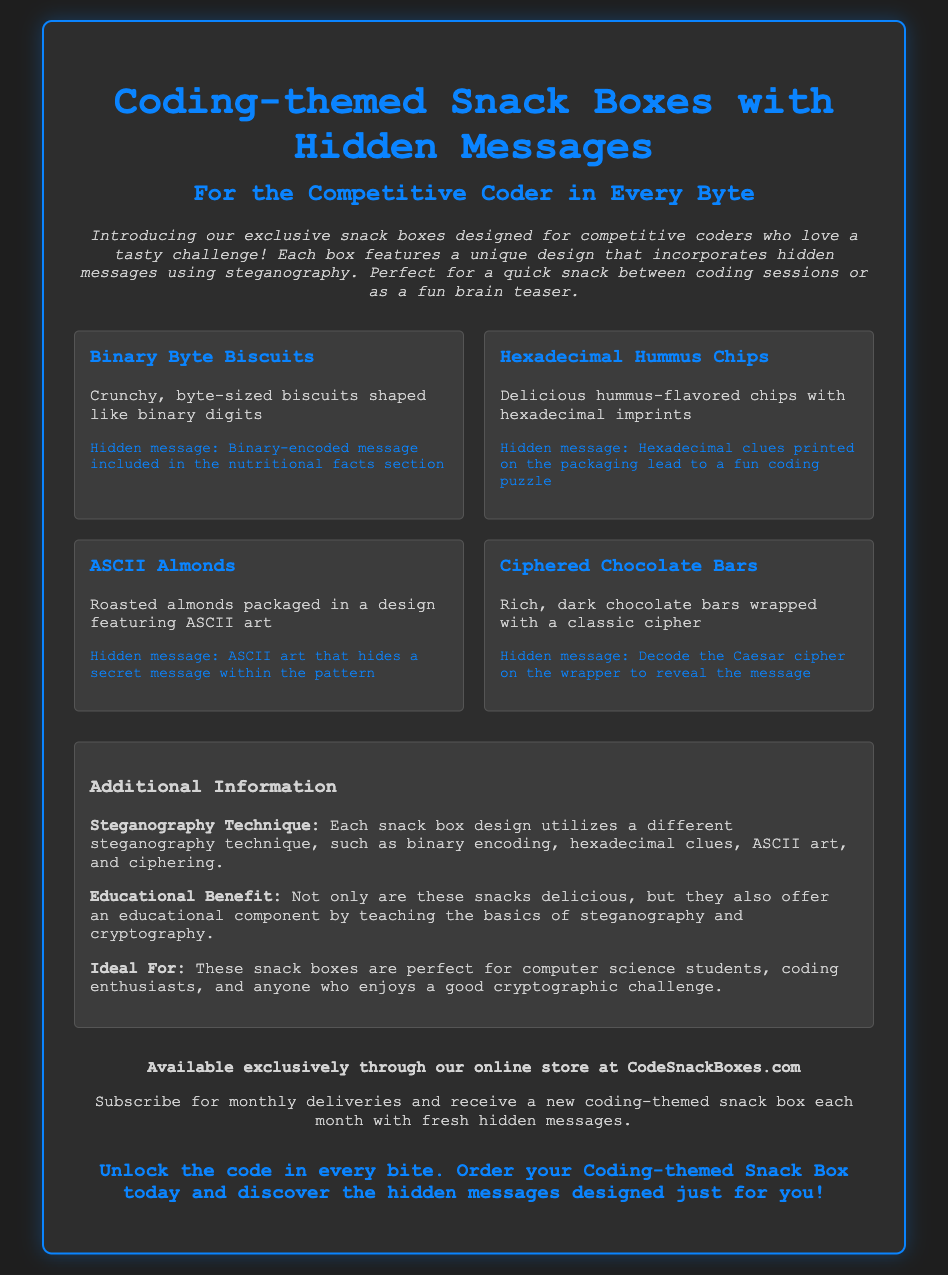What is the name of the product? The title of the product is displayed prominently at the top of the document, stating that it is "Coding-themed Snack Boxes with Hidden Messages."
Answer: Coding-themed Snack Boxes with Hidden Messages What is the ideal audience for these snack boxes? The document mentions that the snack boxes are perfect for "computer science students, coding enthusiasts, and anyone who enjoys a good cryptographic challenge."
Answer: Computer science students, coding enthusiasts, and anyone who enjoys a good cryptographic challenge How many types of snacks are mentioned? The document lists four distinct snack types, which are Binary Byte Biscuits, Hexadecimal Hummus Chips, ASCII Almonds, and Ciphered Chocolate Bars.
Answer: Four What hidden message technique is used for Binary Byte Biscuits? The documentation specifies that the hidden message for Binary Byte Biscuits is encoded in the "nutritional facts section" using binary encoding.
Answer: Binary-encoded message included in the nutritional facts section What is a benefit of this product according to the document? The document states that these snacks offer "an educational component by teaching the basics of steganography and cryptography."
Answer: Educational component by teaching the basics of steganography and cryptography Where can these snack boxes be purchased? The distribution section specifies that these snack boxes are "available exclusively through our online store at CodeSnackBoxes.com."
Answer: CodeSnackBoxes.com How often can subscribers receive snack boxes? The document mentions that subscribers will receive "a new coding-themed snack box each month."
Answer: Monthly What flavor is associated with Hexadecimal Hummus Chips? The document describes Hexadecimal Hummus Chips as "delicious hummus-flavored chips."
Answer: Hummus-flavored Which cryptographic cipher is referenced for Ciphered Chocolate Bars? The document states that the hidden message is to "decode the Caesar cipher" on the wrapper of the chocolate bars.
Answer: Caesar cipher 